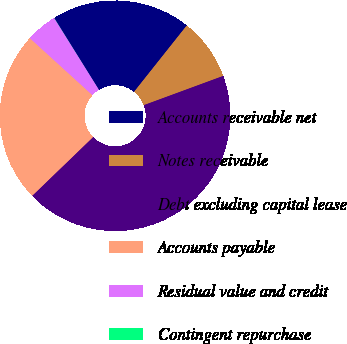Convert chart. <chart><loc_0><loc_0><loc_500><loc_500><pie_chart><fcel>Accounts receivable net<fcel>Notes receivable<fcel>Debt excluding capital lease<fcel>Accounts payable<fcel>Residual value and credit<fcel>Contingent repurchase<nl><fcel>19.54%<fcel>8.7%<fcel>43.4%<fcel>23.97%<fcel>4.36%<fcel>0.02%<nl></chart> 